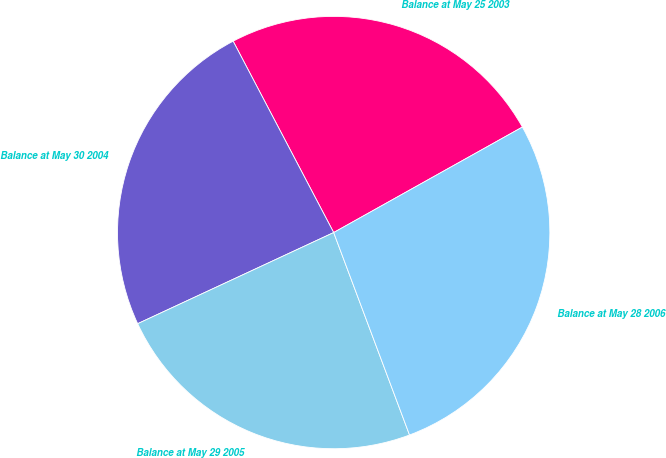<chart> <loc_0><loc_0><loc_500><loc_500><pie_chart><fcel>Balance at May 25 2003<fcel>Balance at May 30 2004<fcel>Balance at May 29 2005<fcel>Balance at May 28 2006<nl><fcel>24.59%<fcel>24.23%<fcel>23.78%<fcel>27.41%<nl></chart> 